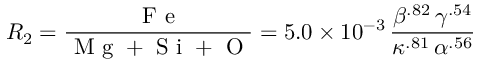Convert formula to latex. <formula><loc_0><loc_0><loc_500><loc_500>R _ { 2 } = \frac { F e } { M g + S i + O } = 5 . 0 \times 1 0 ^ { - 3 } \, \frac { \beta ^ { . 8 2 } \, \gamma ^ { . 5 4 } } { \kappa ^ { . 8 1 } \, \alpha ^ { . 5 6 } }</formula> 